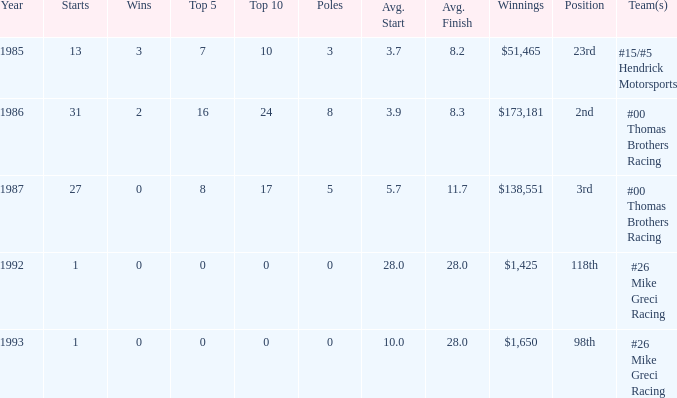For how many years did he maintain an average finish of 1 1.0. 